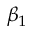<formula> <loc_0><loc_0><loc_500><loc_500>\beta _ { 1 }</formula> 